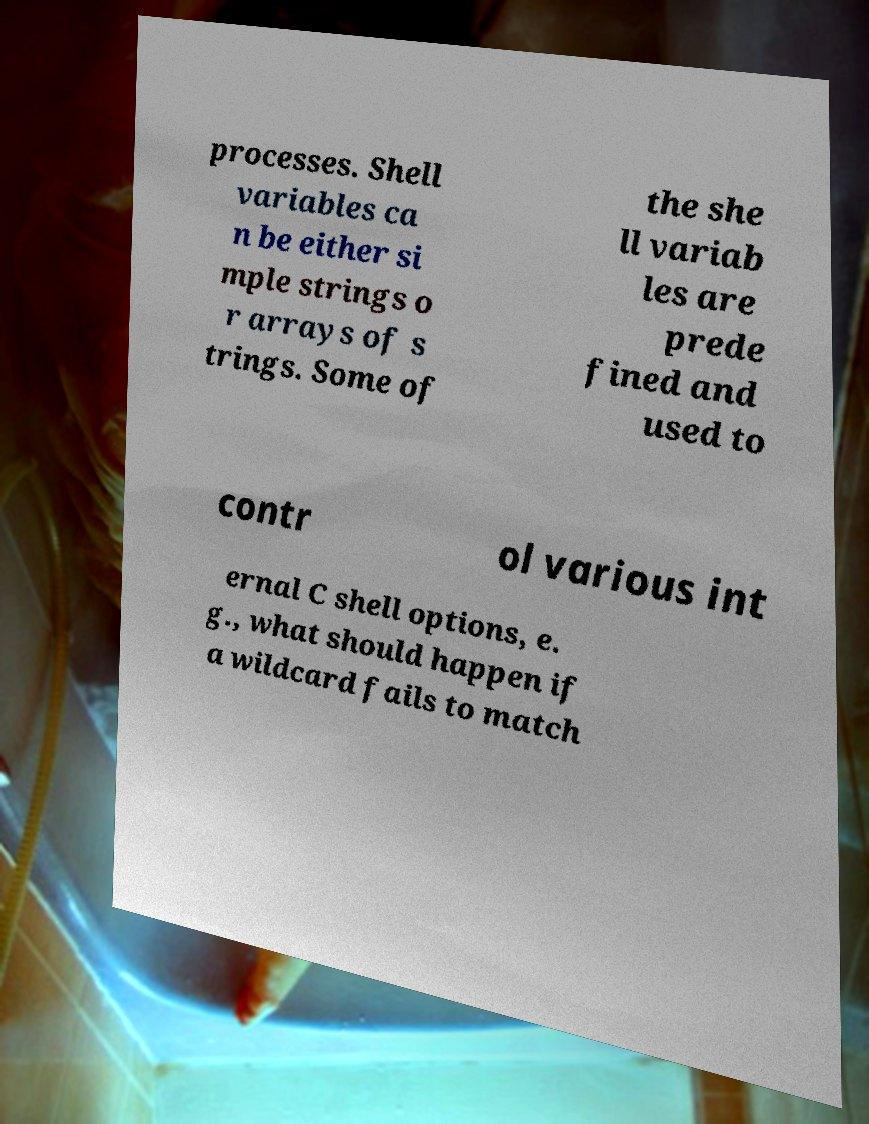Can you read and provide the text displayed in the image?This photo seems to have some interesting text. Can you extract and type it out for me? processes. Shell variables ca n be either si mple strings o r arrays of s trings. Some of the she ll variab les are prede fined and used to contr ol various int ernal C shell options, e. g., what should happen if a wildcard fails to match 